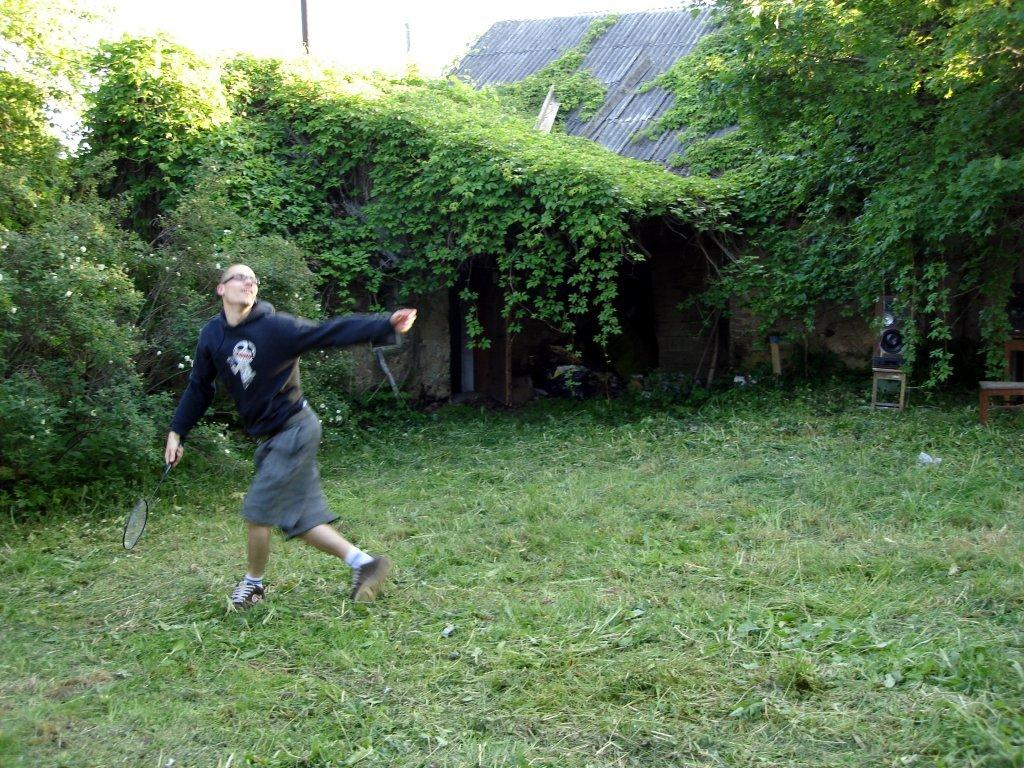Who is present in the image? There is a man in the image. What is the man doing in the image? The man is standing on the grass and holding a tennis racket. What can be seen in the background of the image? There are plants in the background of the image, and they are on asbestos sheets. What type of surface is visible at the bottom of the image? There is grass visible at the bottom of the image. What type of kite is the man flying in the image? There is no kite present in the image; the man is holding a tennis racket. 